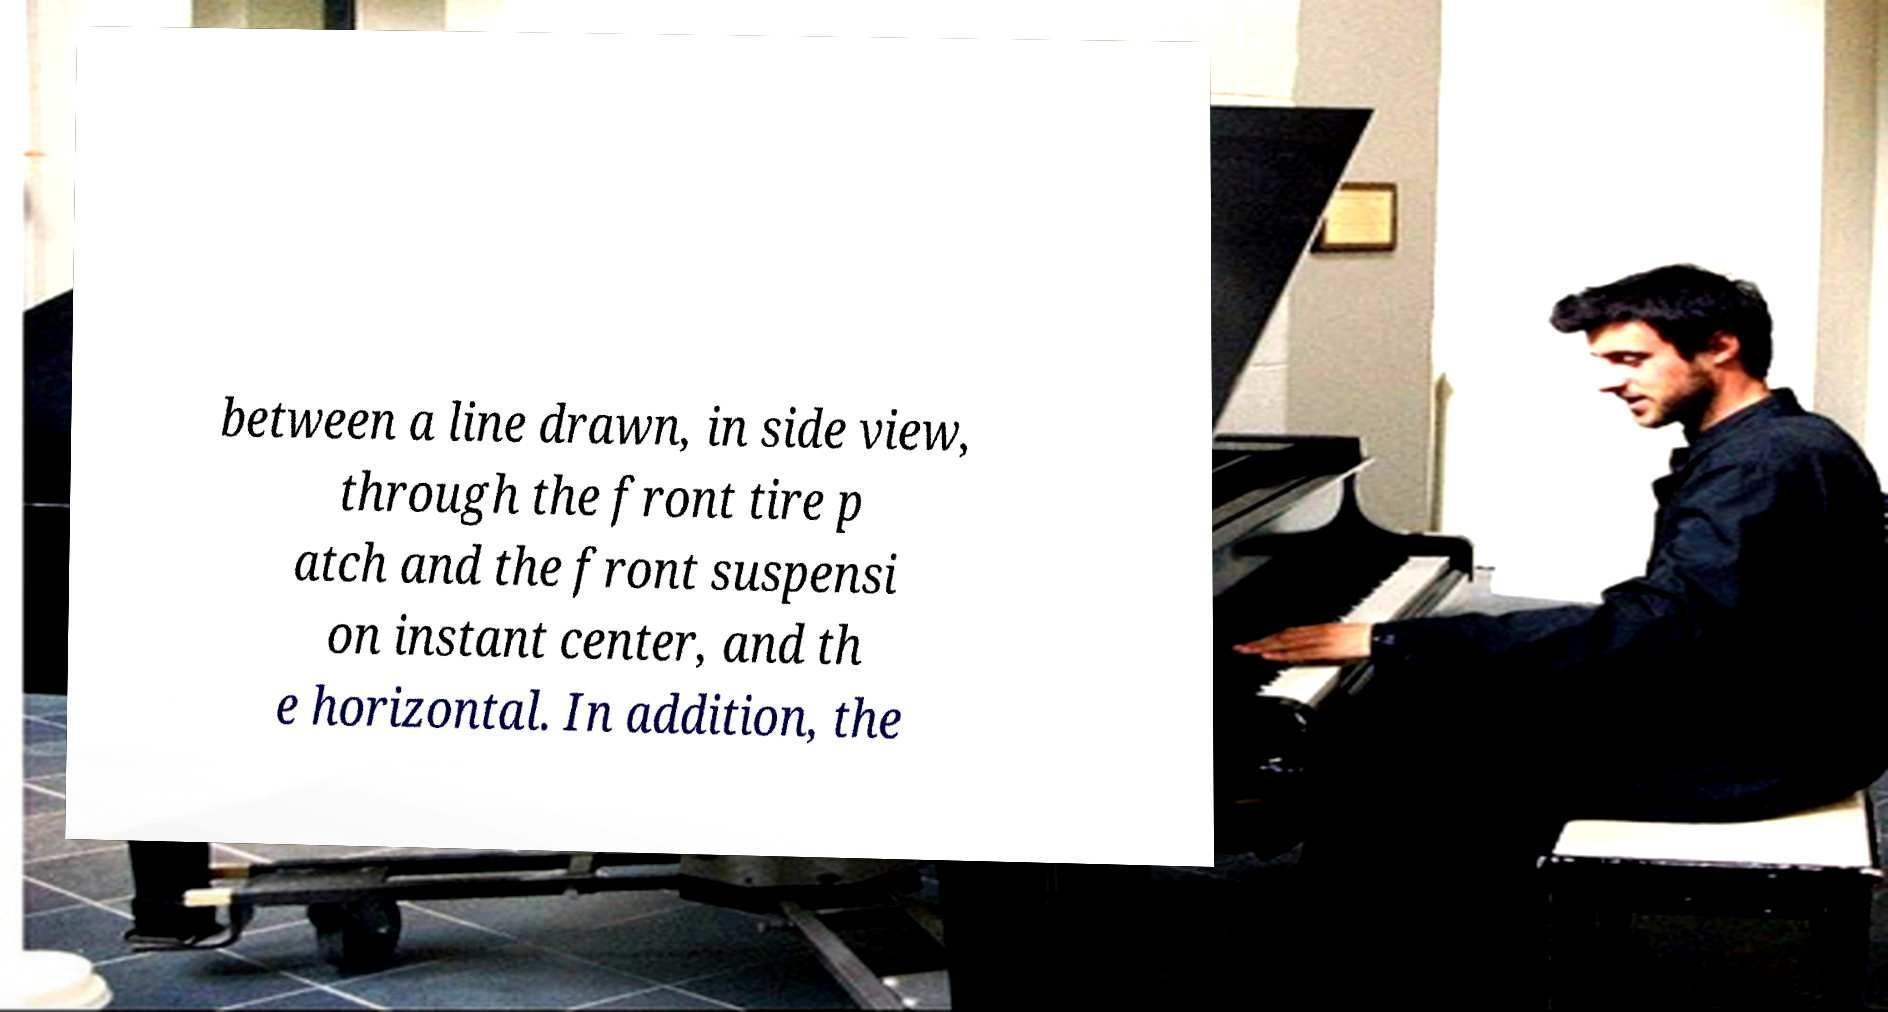What messages or text are displayed in this image? I need them in a readable, typed format. between a line drawn, in side view, through the front tire p atch and the front suspensi on instant center, and th e horizontal. In addition, the 